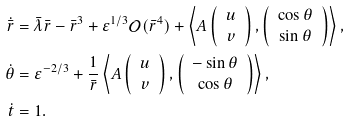Convert formula to latex. <formula><loc_0><loc_0><loc_500><loc_500>\dot { \bar { r } } & = \bar { \lambda } \bar { r } - \bar { r } ^ { 3 } + \varepsilon ^ { 1 / 3 } \mathcal { O } ( \bar { r } ^ { 4 } ) + \left \langle A \left ( \begin{array} { c } u \\ v \end{array} \right ) , \left ( \begin{array} { c } \cos \theta \\ \sin \theta \end{array} \right ) \right \rangle , \\ \dot { \theta } & = \varepsilon ^ { - 2 / 3 } + \frac { 1 } { \bar { r } } \left \langle A \left ( \begin{array} { c } u \\ v \end{array} \right ) , \left ( \begin{array} { c } - \sin \theta \\ \cos \theta \end{array} \right ) \right \rangle , \\ \dot { t } & = 1 .</formula> 